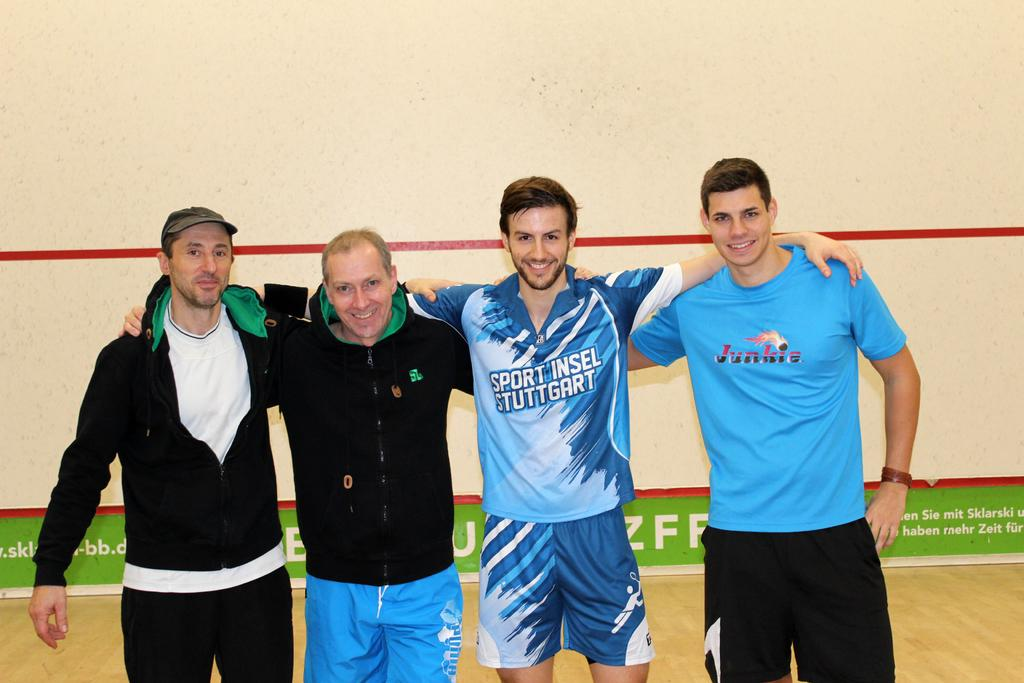Provide a one-sentence caption for the provided image. One of the men in the picture has a t shirt with junkie written on it. 